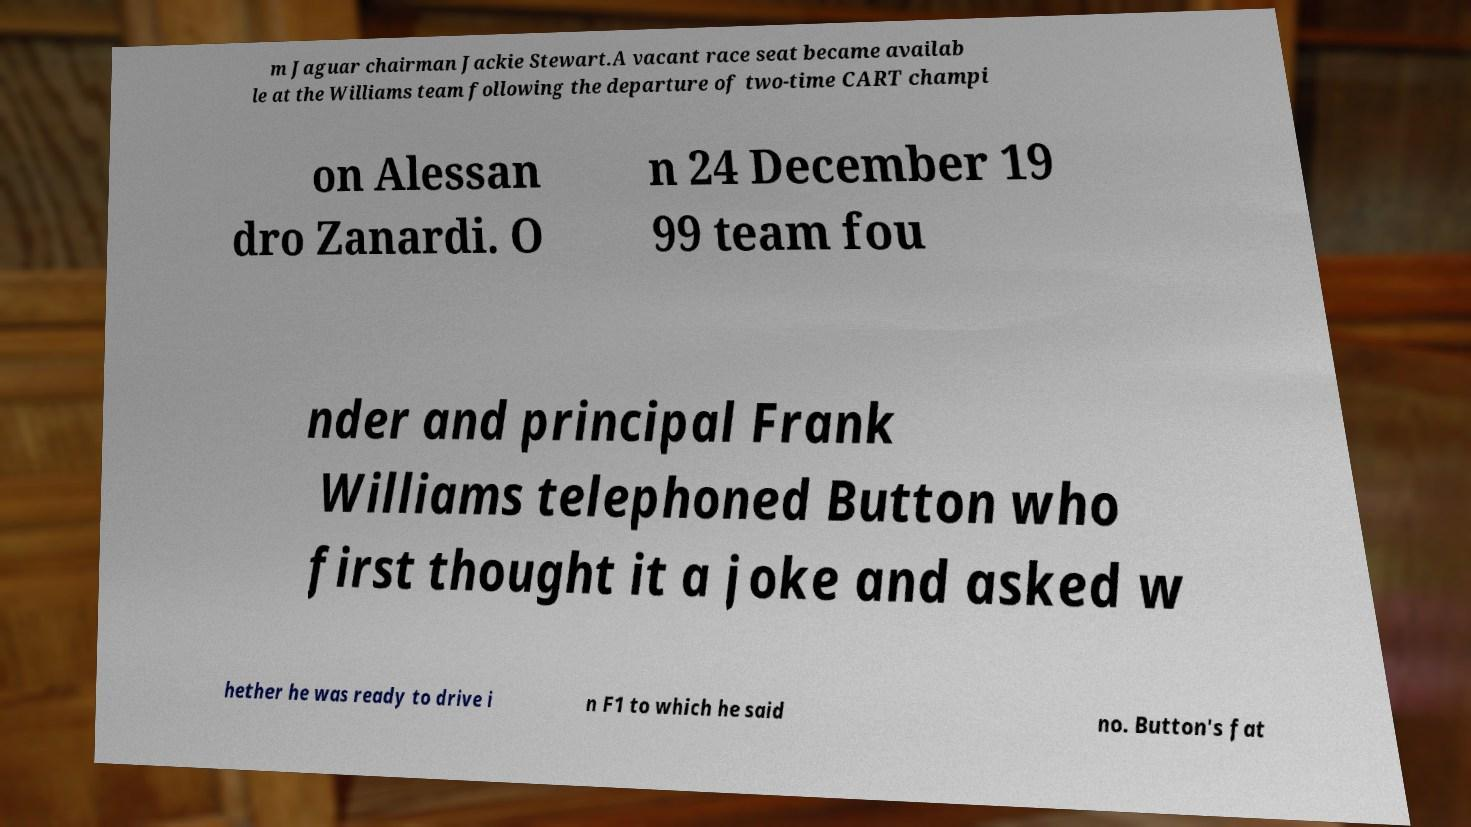Can you accurately transcribe the text from the provided image for me? m Jaguar chairman Jackie Stewart.A vacant race seat became availab le at the Williams team following the departure of two-time CART champi on Alessan dro Zanardi. O n 24 December 19 99 team fou nder and principal Frank Williams telephoned Button who first thought it a joke and asked w hether he was ready to drive i n F1 to which he said no. Button's fat 